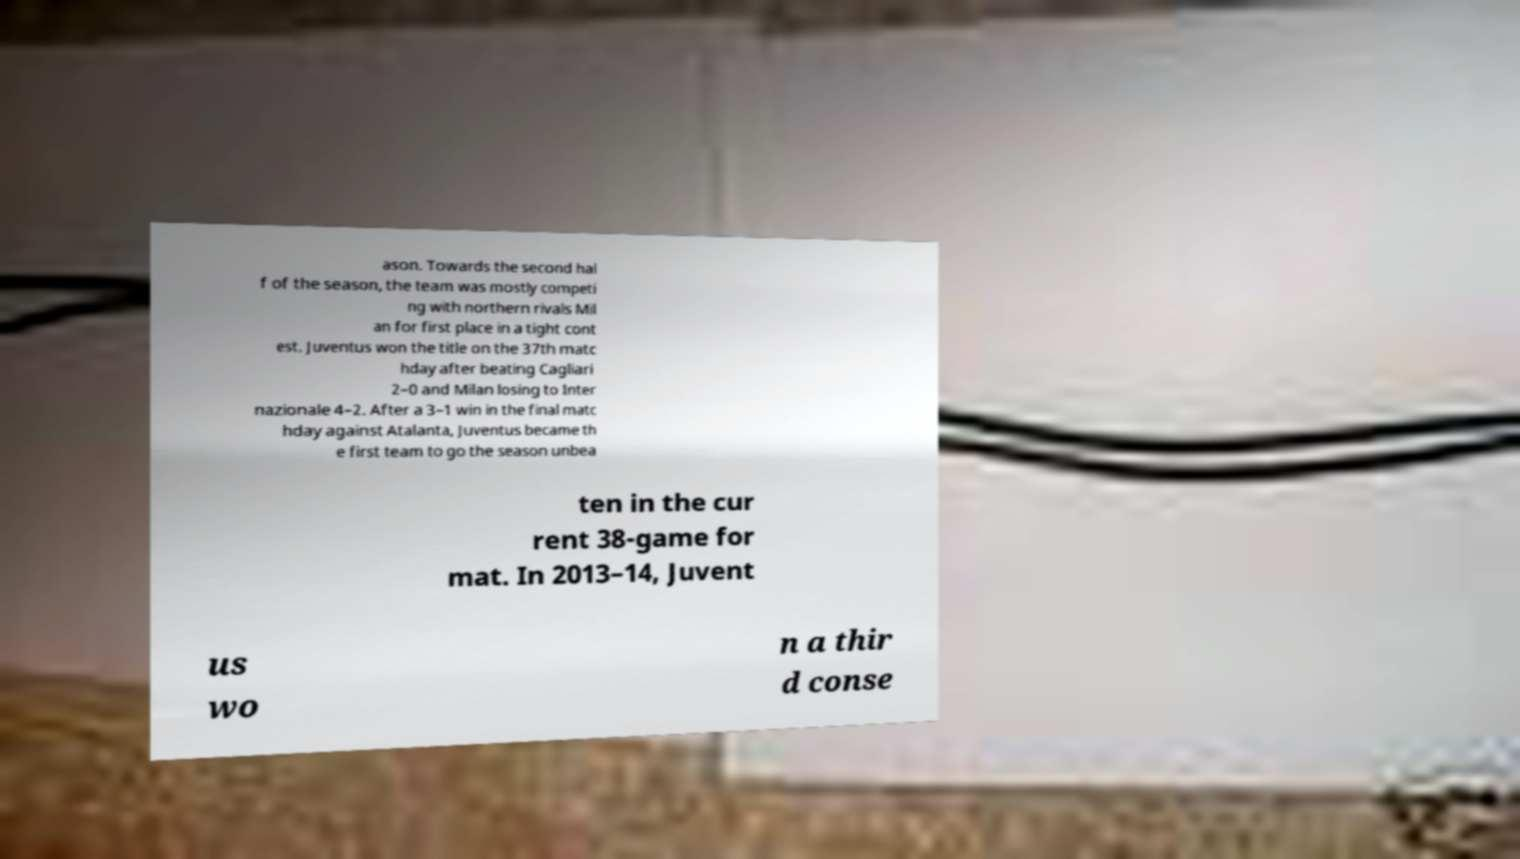I need the written content from this picture converted into text. Can you do that? ason. Towards the second hal f of the season, the team was mostly competi ng with northern rivals Mil an for first place in a tight cont est. Juventus won the title on the 37th matc hday after beating Cagliari 2–0 and Milan losing to Inter nazionale 4–2. After a 3–1 win in the final matc hday against Atalanta, Juventus became th e first team to go the season unbea ten in the cur rent 38-game for mat. In 2013–14, Juvent us wo n a thir d conse 